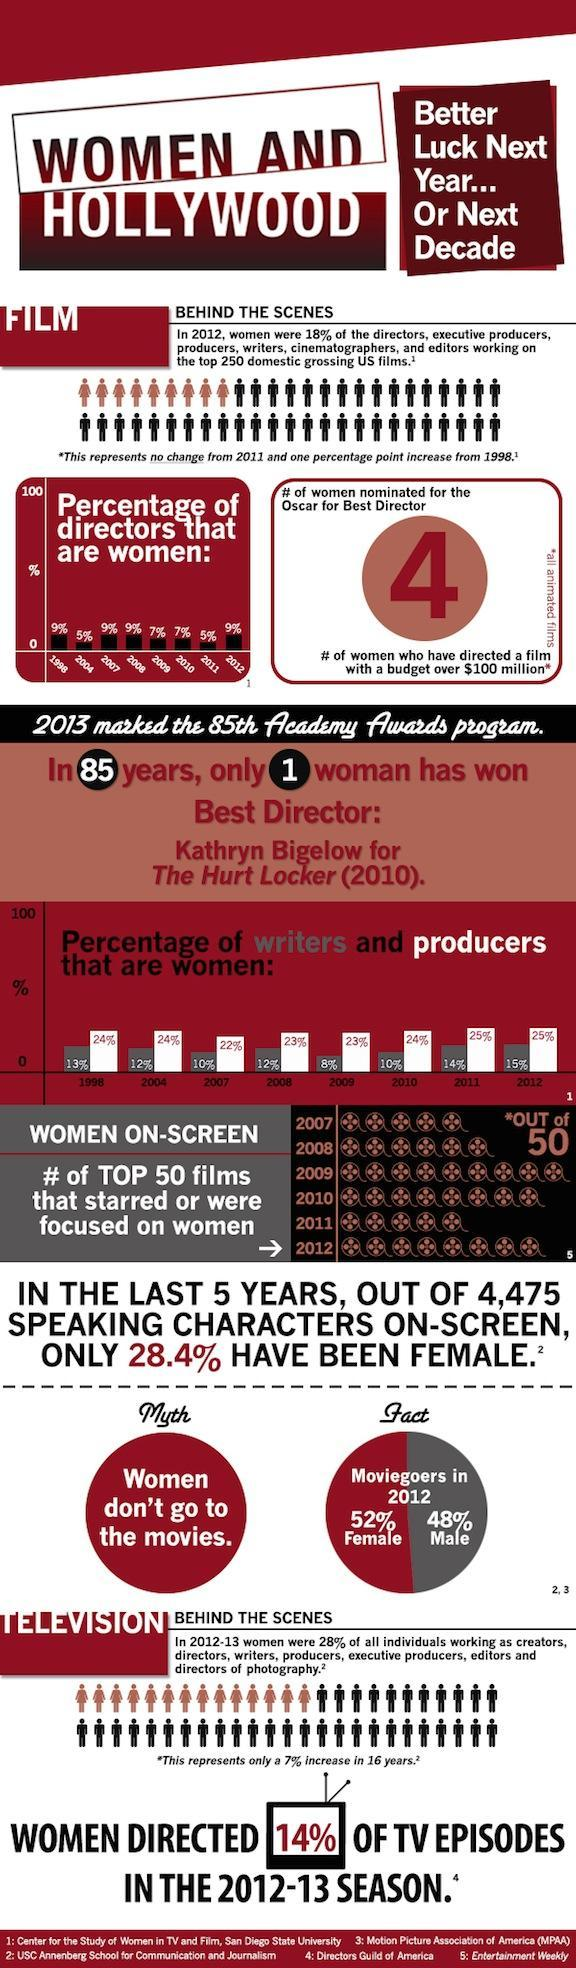What percentage of writers are women in the U.S. film industry in 2008?
Answer the question with a short phrase. 12% What is the number of women nominated for the Oscar for best director in 2012? 4 What percentage of females are moviegoers in 2012? 52% What is the percentage of women directors in Hollywood in 2010? 7% Who is the first woman director to win an Oscar? Kathryn Bigelow What percentage of producers are women in the U.S. film industry in 2010? 24% What percentage of writers are women in the U.S. film industry in 2012? 15% How many Hollywood films starred or focussed on women among the top 50 films in 2011? 5 